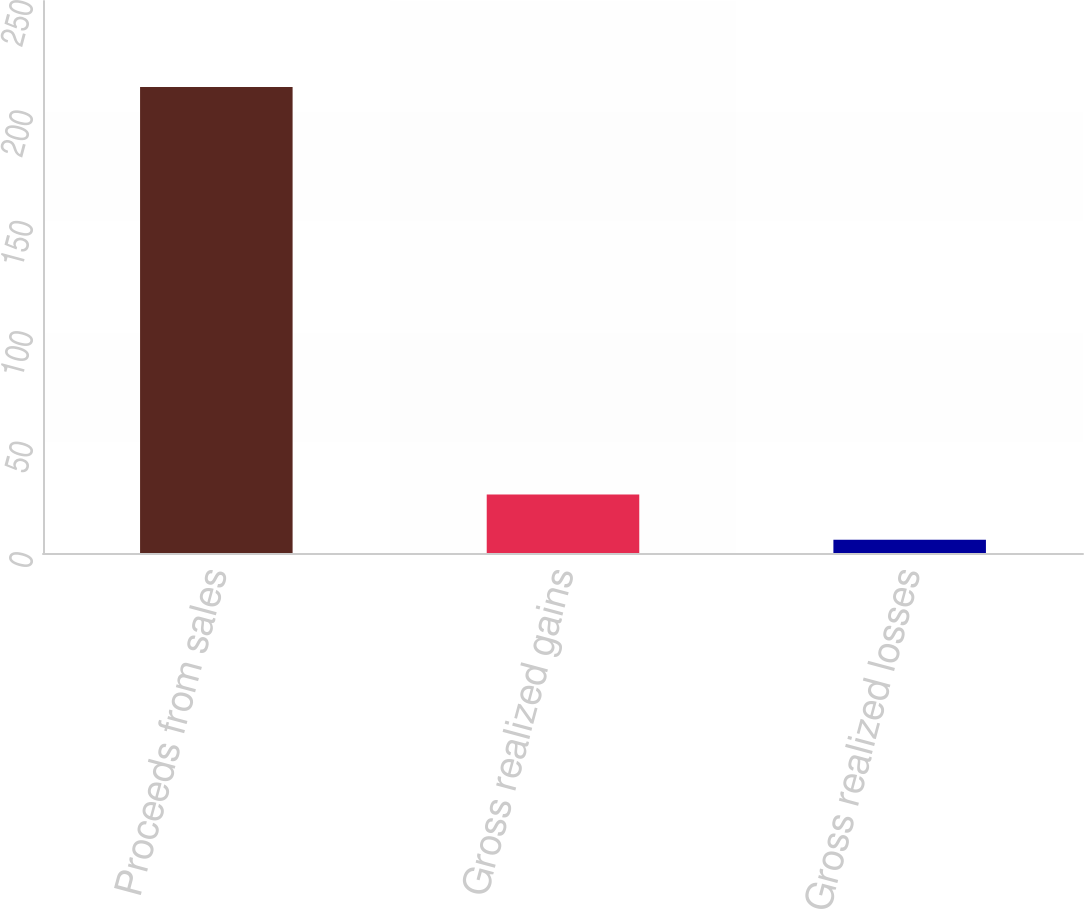Convert chart. <chart><loc_0><loc_0><loc_500><loc_500><bar_chart><fcel>Proceeds from sales<fcel>Gross realized gains<fcel>Gross realized losses<nl><fcel>211<fcel>26.5<fcel>6<nl></chart> 